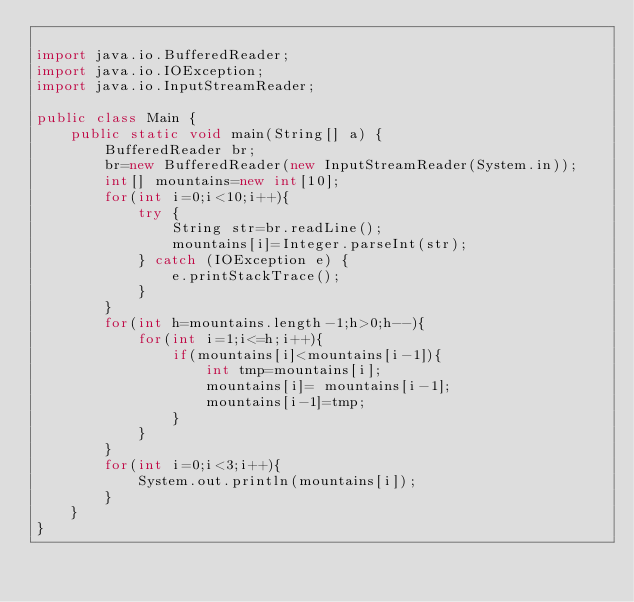Convert code to text. <code><loc_0><loc_0><loc_500><loc_500><_Java_>
import java.io.BufferedReader;
import java.io.IOException;
import java.io.InputStreamReader;

public class Main {
	public static void main(String[] a) {
		BufferedReader br;
		br=new BufferedReader(new InputStreamReader(System.in));
		int[] mountains=new int[10];
        for(int i=0;i<10;i++){
            try {
                String str=br.readLine();
                mountains[i]=Integer.parseInt(str);
            } catch (IOException e) {
                e.printStackTrace();
            }
        }
		for(int h=mountains.length-1;h>0;h--){
			for(int i=1;i<=h;i++){
				if(mountains[i]<mountains[i-1]){
					int tmp=mountains[i];
					mountains[i]= mountains[i-1];
					mountains[i-1]=tmp;
				}
			}
		}
		for(int i=0;i<3;i++){
			System.out.println(mountains[i]);
		}
	}
}</code> 